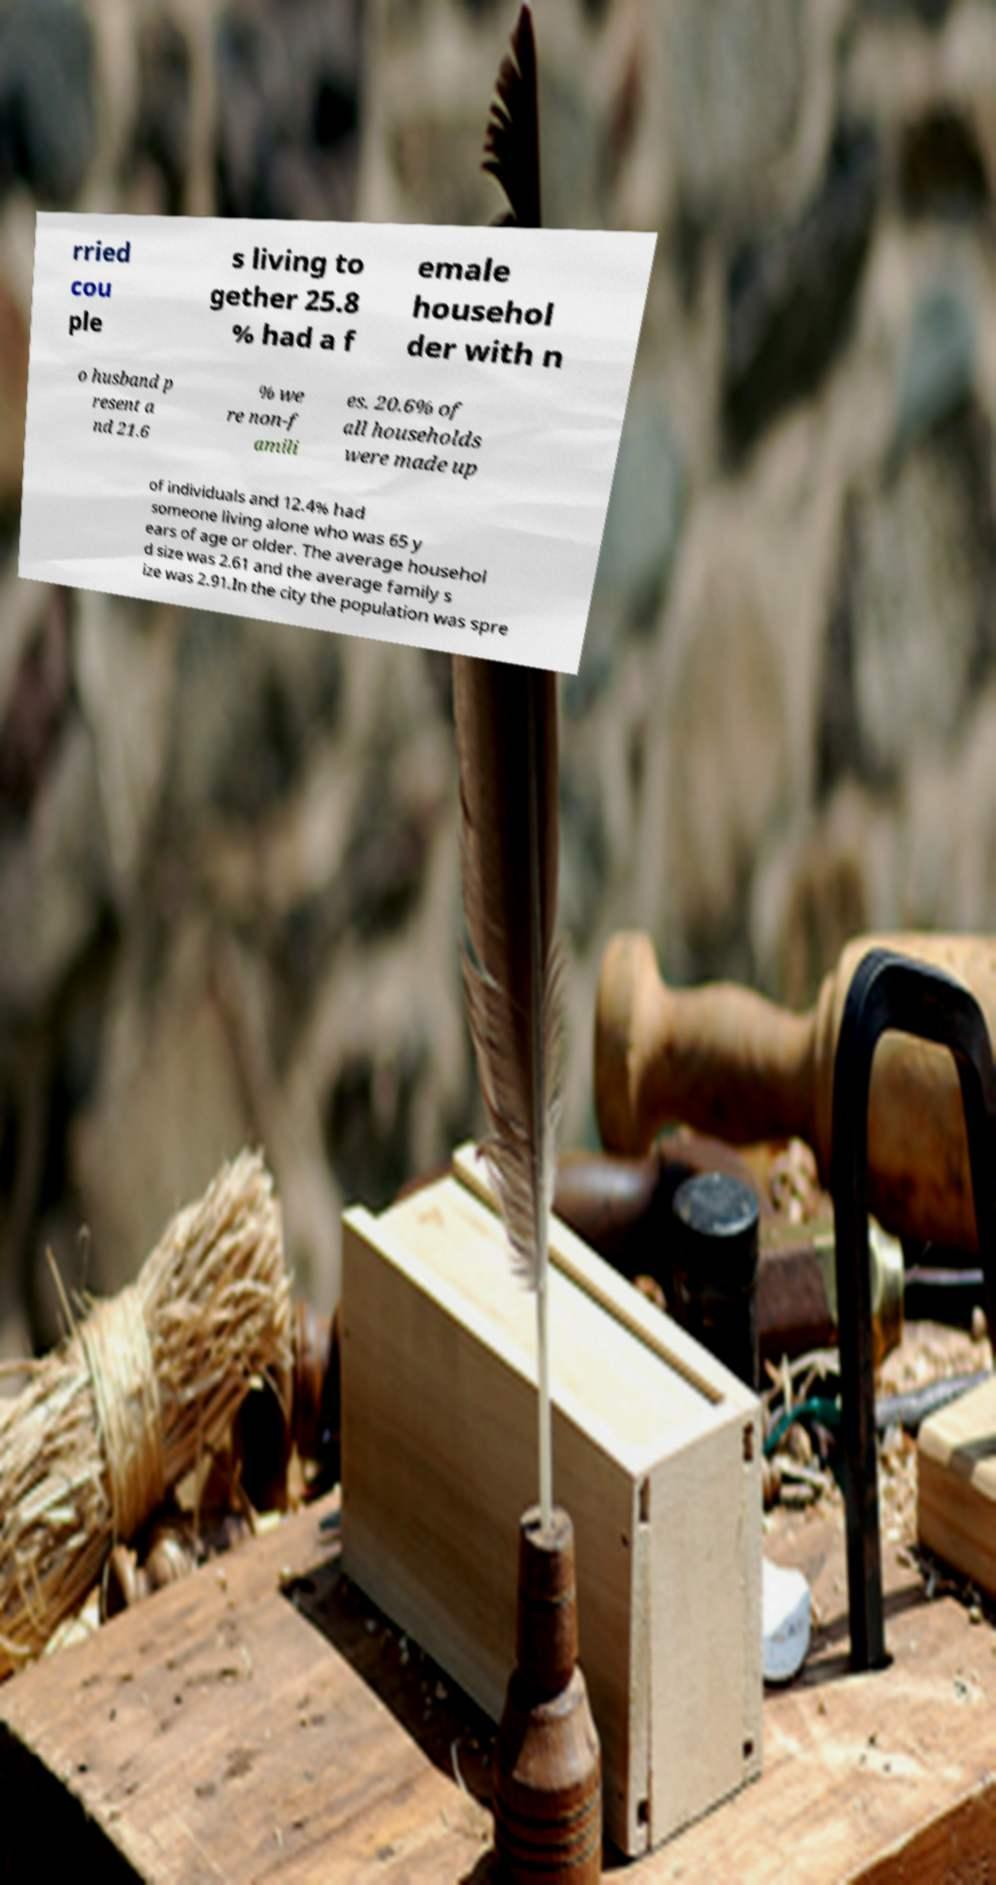There's text embedded in this image that I need extracted. Can you transcribe it verbatim? rried cou ple s living to gether 25.8 % had a f emale househol der with n o husband p resent a nd 21.6 % we re non-f amili es. 20.6% of all households were made up of individuals and 12.4% had someone living alone who was 65 y ears of age or older. The average househol d size was 2.61 and the average family s ize was 2.91.In the city the population was spre 